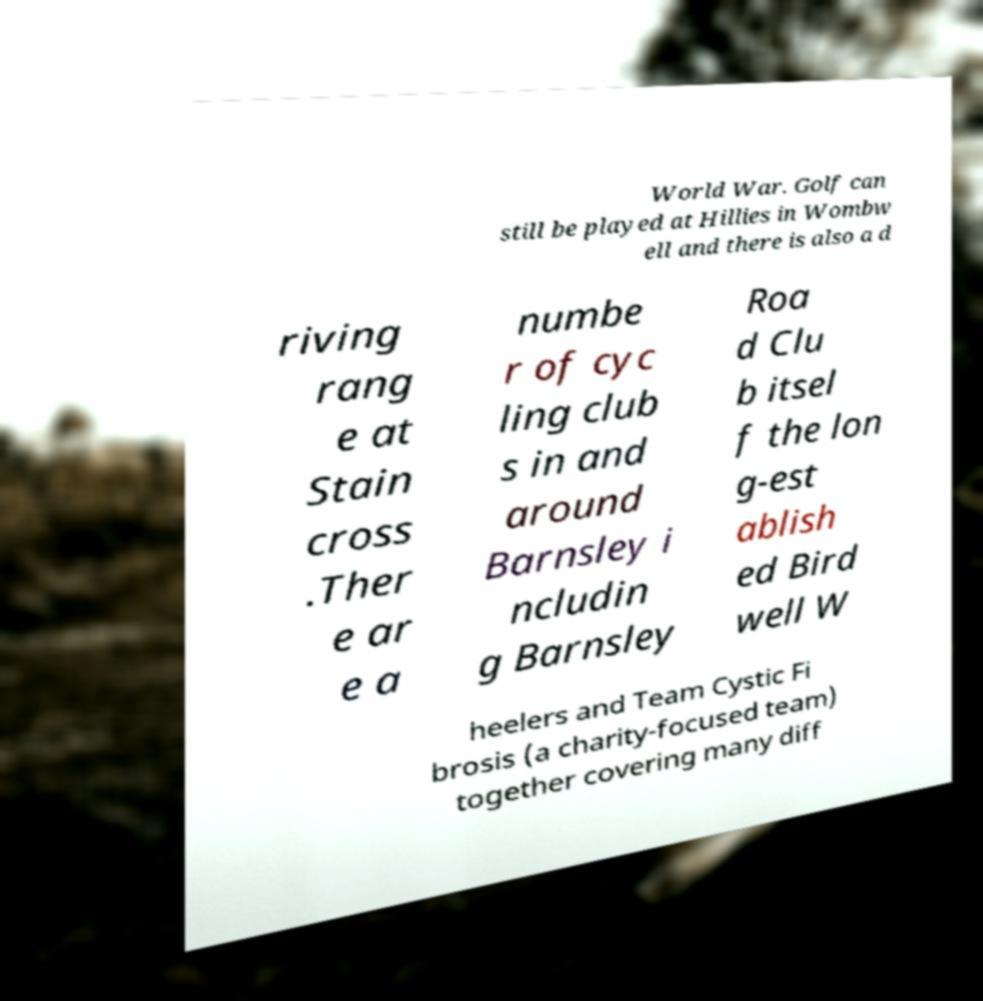Can you accurately transcribe the text from the provided image for me? World War. Golf can still be played at Hillies in Wombw ell and there is also a d riving rang e at Stain cross .Ther e ar e a numbe r of cyc ling club s in and around Barnsley i ncludin g Barnsley Roa d Clu b itsel f the lon g-est ablish ed Bird well W heelers and Team Cystic Fi brosis (a charity-focused team) together covering many diff 